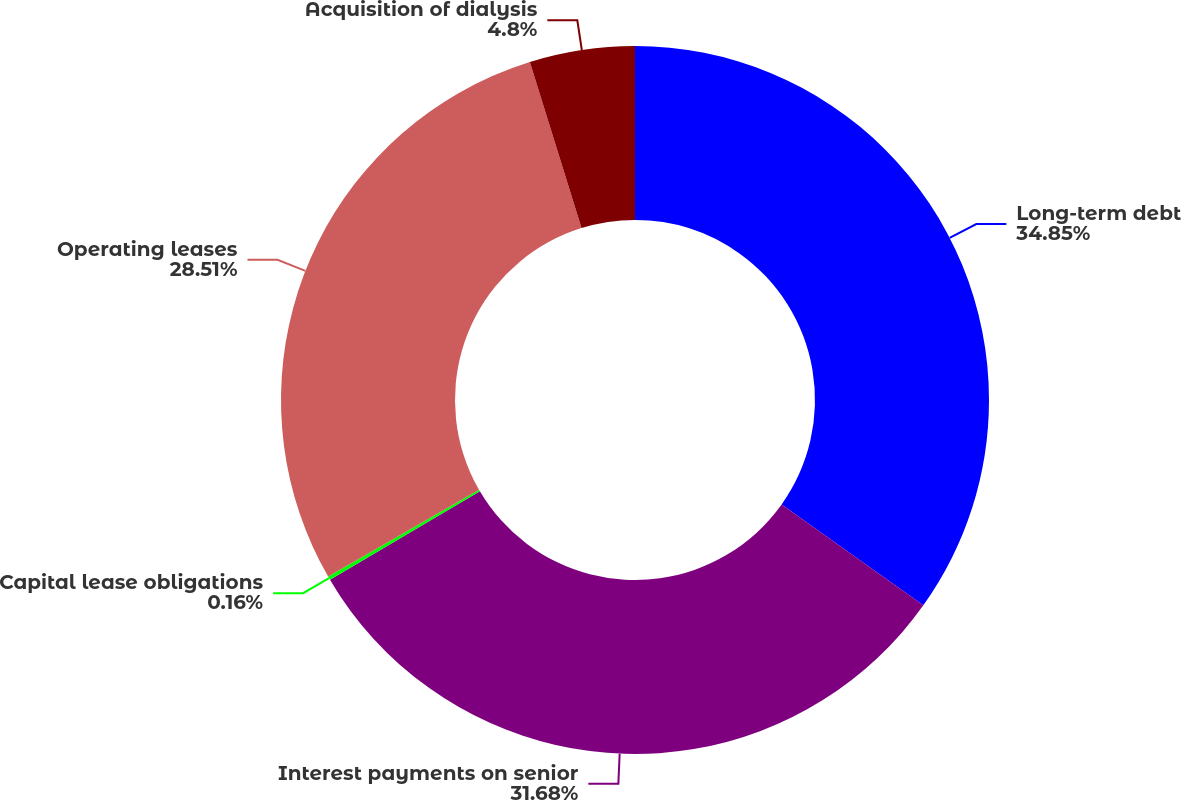Convert chart to OTSL. <chart><loc_0><loc_0><loc_500><loc_500><pie_chart><fcel>Long-term debt<fcel>Interest payments on senior<fcel>Capital lease obligations<fcel>Operating leases<fcel>Acquisition of dialysis<nl><fcel>34.85%<fcel>31.68%<fcel>0.16%<fcel>28.51%<fcel>4.8%<nl></chart> 